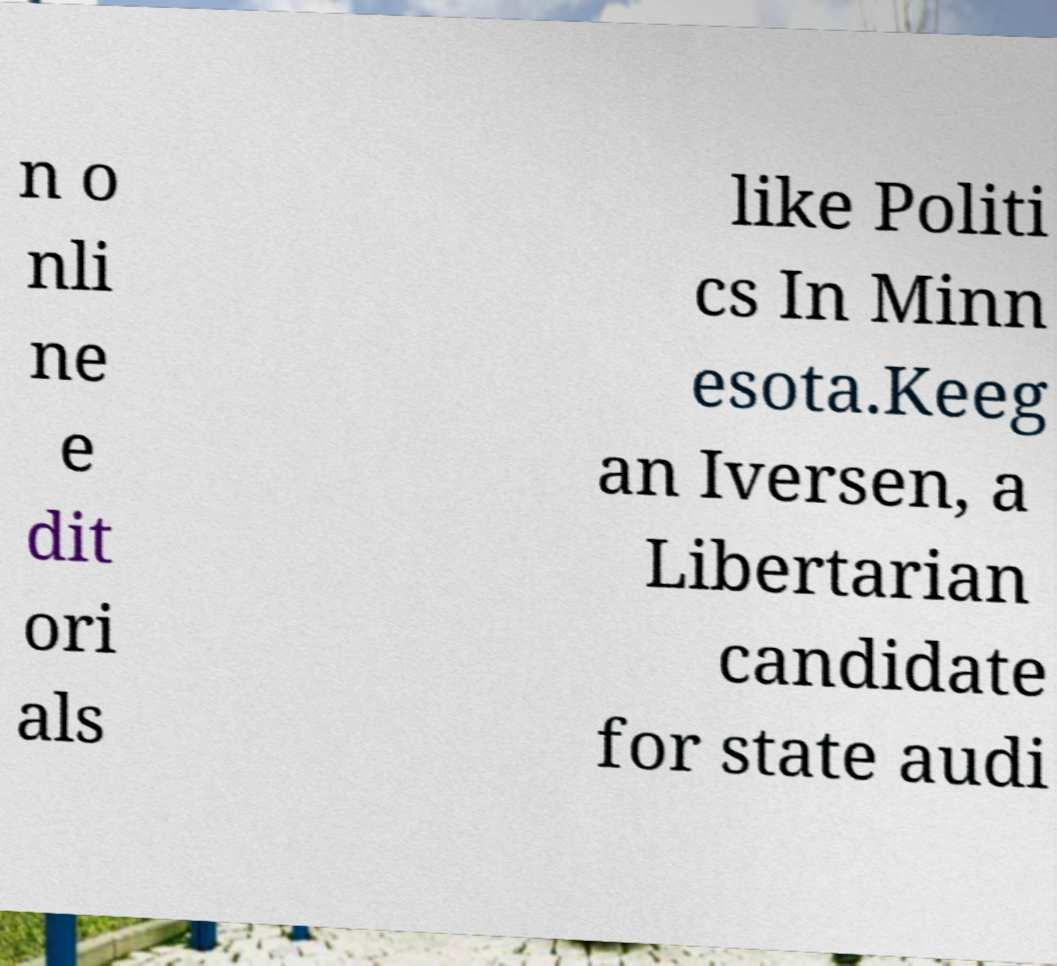Please read and relay the text visible in this image. What does it say? n o nli ne e dit ori als like Politi cs In Minn esota.Keeg an Iversen, a Libertarian candidate for state audi 